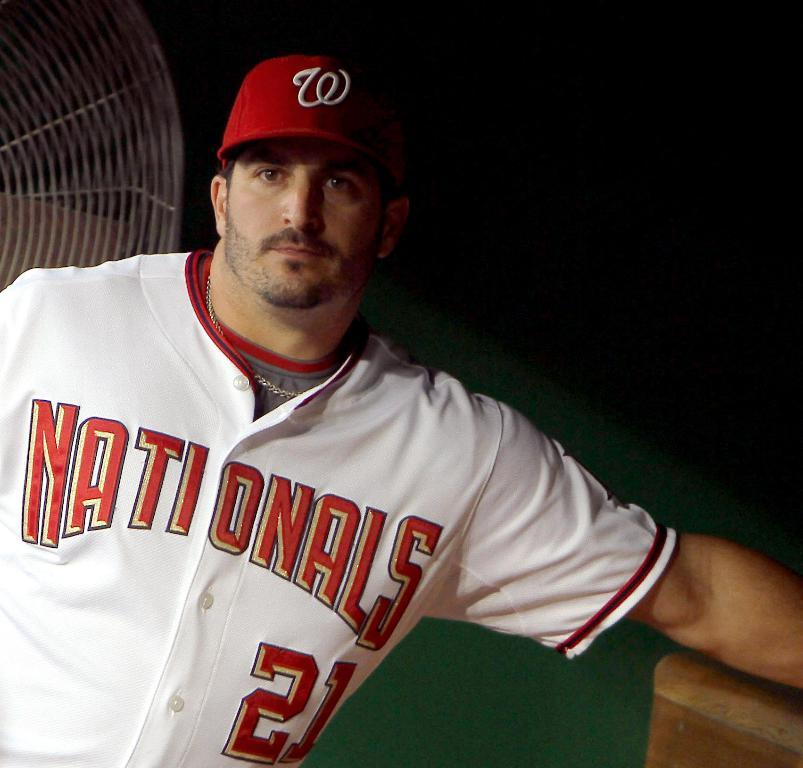<image>
Write a terse but informative summary of the picture. A man wearing a Washington Nationals baseball uniform is posing in the dugout. 